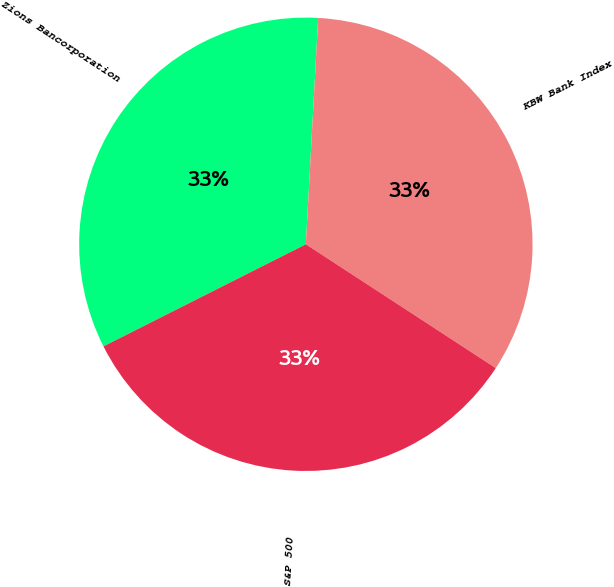<chart> <loc_0><loc_0><loc_500><loc_500><pie_chart><fcel>Zions Bancorporation<fcel>KBW Bank Index<fcel>S&P 500<nl><fcel>33.3%<fcel>33.33%<fcel>33.37%<nl></chart> 